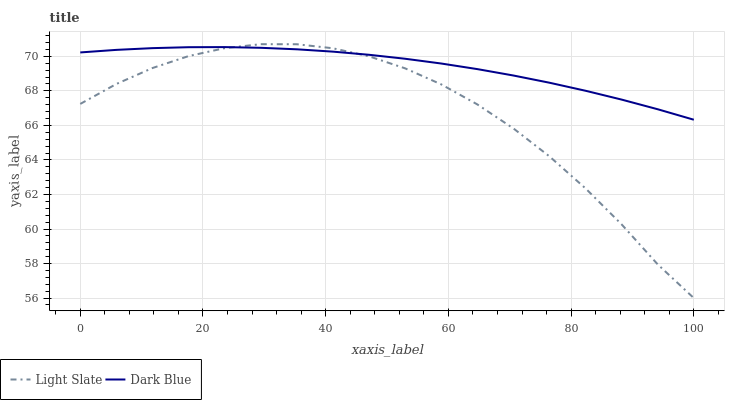Does Light Slate have the minimum area under the curve?
Answer yes or no. Yes. Does Dark Blue have the maximum area under the curve?
Answer yes or no. Yes. Does Dark Blue have the minimum area under the curve?
Answer yes or no. No. Is Dark Blue the smoothest?
Answer yes or no. Yes. Is Light Slate the roughest?
Answer yes or no. Yes. Is Dark Blue the roughest?
Answer yes or no. No. Does Dark Blue have the lowest value?
Answer yes or no. No. Does Light Slate have the highest value?
Answer yes or no. Yes. Does Dark Blue have the highest value?
Answer yes or no. No. Does Light Slate intersect Dark Blue?
Answer yes or no. Yes. Is Light Slate less than Dark Blue?
Answer yes or no. No. Is Light Slate greater than Dark Blue?
Answer yes or no. No. 